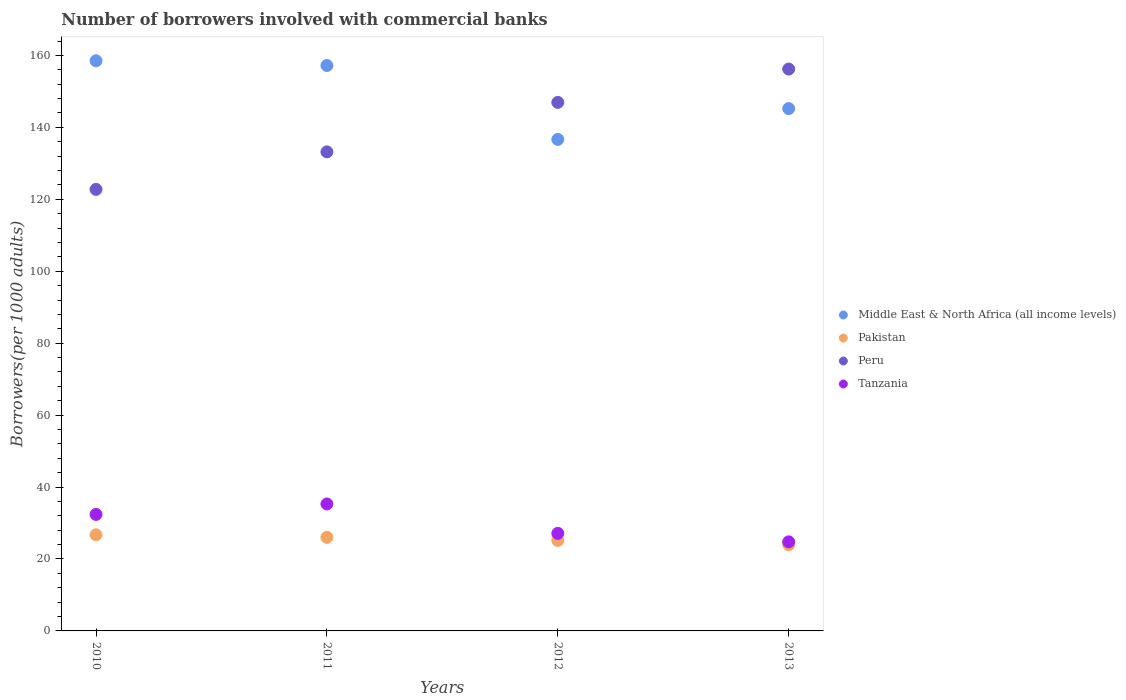What is the number of borrowers involved with commercial banks in Peru in 2013?
Offer a very short reply. 156.21. Across all years, what is the maximum number of borrowers involved with commercial banks in Peru?
Keep it short and to the point. 156.21. Across all years, what is the minimum number of borrowers involved with commercial banks in Peru?
Provide a short and direct response. 122.75. In which year was the number of borrowers involved with commercial banks in Peru maximum?
Your answer should be compact. 2013. What is the total number of borrowers involved with commercial banks in Tanzania in the graph?
Offer a very short reply. 119.57. What is the difference between the number of borrowers involved with commercial banks in Tanzania in 2012 and that in 2013?
Give a very brief answer. 2.35. What is the difference between the number of borrowers involved with commercial banks in Tanzania in 2010 and the number of borrowers involved with commercial banks in Pakistan in 2012?
Provide a short and direct response. 7.24. What is the average number of borrowers involved with commercial banks in Pakistan per year?
Your answer should be very brief. 25.46. In the year 2012, what is the difference between the number of borrowers involved with commercial banks in Tanzania and number of borrowers involved with commercial banks in Peru?
Provide a succinct answer. -119.83. In how many years, is the number of borrowers involved with commercial banks in Peru greater than 8?
Provide a short and direct response. 4. What is the ratio of the number of borrowers involved with commercial banks in Pakistan in 2010 to that in 2013?
Offer a terse response. 1.12. Is the number of borrowers involved with commercial banks in Peru in 2012 less than that in 2013?
Provide a succinct answer. Yes. What is the difference between the highest and the second highest number of borrowers involved with commercial banks in Pakistan?
Ensure brevity in your answer.  0.72. What is the difference between the highest and the lowest number of borrowers involved with commercial banks in Tanzania?
Ensure brevity in your answer.  10.53. Is the sum of the number of borrowers involved with commercial banks in Tanzania in 2011 and 2012 greater than the maximum number of borrowers involved with commercial banks in Pakistan across all years?
Give a very brief answer. Yes. Is it the case that in every year, the sum of the number of borrowers involved with commercial banks in Tanzania and number of borrowers involved with commercial banks in Pakistan  is greater than the number of borrowers involved with commercial banks in Middle East & North Africa (all income levels)?
Your answer should be compact. No. Does the number of borrowers involved with commercial banks in Pakistan monotonically increase over the years?
Your answer should be very brief. No. Is the number of borrowers involved with commercial banks in Tanzania strictly greater than the number of borrowers involved with commercial banks in Middle East & North Africa (all income levels) over the years?
Provide a succinct answer. No. Are the values on the major ticks of Y-axis written in scientific E-notation?
Offer a very short reply. No. Does the graph contain grids?
Make the answer very short. No. How many legend labels are there?
Make the answer very short. 4. What is the title of the graph?
Your answer should be compact. Number of borrowers involved with commercial banks. Does "Mauritius" appear as one of the legend labels in the graph?
Provide a succinct answer. No. What is the label or title of the Y-axis?
Your response must be concise. Borrowers(per 1000 adults). What is the Borrowers(per 1000 adults) of Middle East & North Africa (all income levels) in 2010?
Your response must be concise. 158.51. What is the Borrowers(per 1000 adults) in Pakistan in 2010?
Ensure brevity in your answer.  26.73. What is the Borrowers(per 1000 adults) of Peru in 2010?
Give a very brief answer. 122.75. What is the Borrowers(per 1000 adults) of Tanzania in 2010?
Offer a very short reply. 32.39. What is the Borrowers(per 1000 adults) in Middle East & North Africa (all income levels) in 2011?
Your answer should be compact. 157.2. What is the Borrowers(per 1000 adults) of Pakistan in 2011?
Offer a very short reply. 26.01. What is the Borrowers(per 1000 adults) in Peru in 2011?
Your answer should be very brief. 133.19. What is the Borrowers(per 1000 adults) of Tanzania in 2011?
Your answer should be very brief. 35.3. What is the Borrowers(per 1000 adults) in Middle East & North Africa (all income levels) in 2012?
Give a very brief answer. 136.65. What is the Borrowers(per 1000 adults) in Pakistan in 2012?
Make the answer very short. 25.15. What is the Borrowers(per 1000 adults) in Peru in 2012?
Give a very brief answer. 146.94. What is the Borrowers(per 1000 adults) of Tanzania in 2012?
Keep it short and to the point. 27.12. What is the Borrowers(per 1000 adults) of Middle East & North Africa (all income levels) in 2013?
Ensure brevity in your answer.  145.22. What is the Borrowers(per 1000 adults) of Pakistan in 2013?
Give a very brief answer. 23.97. What is the Borrowers(per 1000 adults) in Peru in 2013?
Give a very brief answer. 156.21. What is the Borrowers(per 1000 adults) in Tanzania in 2013?
Provide a succinct answer. 24.77. Across all years, what is the maximum Borrowers(per 1000 adults) of Middle East & North Africa (all income levels)?
Keep it short and to the point. 158.51. Across all years, what is the maximum Borrowers(per 1000 adults) in Pakistan?
Give a very brief answer. 26.73. Across all years, what is the maximum Borrowers(per 1000 adults) of Peru?
Keep it short and to the point. 156.21. Across all years, what is the maximum Borrowers(per 1000 adults) of Tanzania?
Your answer should be compact. 35.3. Across all years, what is the minimum Borrowers(per 1000 adults) in Middle East & North Africa (all income levels)?
Offer a terse response. 136.65. Across all years, what is the minimum Borrowers(per 1000 adults) of Pakistan?
Provide a short and direct response. 23.97. Across all years, what is the minimum Borrowers(per 1000 adults) in Peru?
Ensure brevity in your answer.  122.75. Across all years, what is the minimum Borrowers(per 1000 adults) of Tanzania?
Your response must be concise. 24.77. What is the total Borrowers(per 1000 adults) of Middle East & North Africa (all income levels) in the graph?
Your answer should be compact. 597.58. What is the total Borrowers(per 1000 adults) of Pakistan in the graph?
Provide a succinct answer. 101.85. What is the total Borrowers(per 1000 adults) of Peru in the graph?
Provide a succinct answer. 559.09. What is the total Borrowers(per 1000 adults) of Tanzania in the graph?
Your answer should be compact. 119.57. What is the difference between the Borrowers(per 1000 adults) in Middle East & North Africa (all income levels) in 2010 and that in 2011?
Provide a succinct answer. 1.32. What is the difference between the Borrowers(per 1000 adults) in Pakistan in 2010 and that in 2011?
Offer a terse response. 0.72. What is the difference between the Borrowers(per 1000 adults) of Peru in 2010 and that in 2011?
Offer a very short reply. -10.43. What is the difference between the Borrowers(per 1000 adults) of Tanzania in 2010 and that in 2011?
Your answer should be compact. -2.91. What is the difference between the Borrowers(per 1000 adults) of Middle East & North Africa (all income levels) in 2010 and that in 2012?
Your response must be concise. 21.87. What is the difference between the Borrowers(per 1000 adults) in Pakistan in 2010 and that in 2012?
Your answer should be very brief. 1.58. What is the difference between the Borrowers(per 1000 adults) in Peru in 2010 and that in 2012?
Offer a terse response. -24.19. What is the difference between the Borrowers(per 1000 adults) of Tanzania in 2010 and that in 2012?
Make the answer very short. 5.28. What is the difference between the Borrowers(per 1000 adults) in Middle East & North Africa (all income levels) in 2010 and that in 2013?
Your answer should be compact. 13.29. What is the difference between the Borrowers(per 1000 adults) of Pakistan in 2010 and that in 2013?
Your answer should be very brief. 2.76. What is the difference between the Borrowers(per 1000 adults) in Peru in 2010 and that in 2013?
Your answer should be very brief. -33.46. What is the difference between the Borrowers(per 1000 adults) in Tanzania in 2010 and that in 2013?
Keep it short and to the point. 7.63. What is the difference between the Borrowers(per 1000 adults) in Middle East & North Africa (all income levels) in 2011 and that in 2012?
Offer a terse response. 20.55. What is the difference between the Borrowers(per 1000 adults) of Pakistan in 2011 and that in 2012?
Provide a succinct answer. 0.86. What is the difference between the Borrowers(per 1000 adults) of Peru in 2011 and that in 2012?
Offer a very short reply. -13.75. What is the difference between the Borrowers(per 1000 adults) of Tanzania in 2011 and that in 2012?
Offer a very short reply. 8.18. What is the difference between the Borrowers(per 1000 adults) of Middle East & North Africa (all income levels) in 2011 and that in 2013?
Your answer should be very brief. 11.98. What is the difference between the Borrowers(per 1000 adults) of Pakistan in 2011 and that in 2013?
Keep it short and to the point. 2.04. What is the difference between the Borrowers(per 1000 adults) in Peru in 2011 and that in 2013?
Keep it short and to the point. -23.02. What is the difference between the Borrowers(per 1000 adults) in Tanzania in 2011 and that in 2013?
Make the answer very short. 10.53. What is the difference between the Borrowers(per 1000 adults) of Middle East & North Africa (all income levels) in 2012 and that in 2013?
Provide a short and direct response. -8.58. What is the difference between the Borrowers(per 1000 adults) in Pakistan in 2012 and that in 2013?
Offer a terse response. 1.18. What is the difference between the Borrowers(per 1000 adults) in Peru in 2012 and that in 2013?
Provide a succinct answer. -9.27. What is the difference between the Borrowers(per 1000 adults) of Tanzania in 2012 and that in 2013?
Ensure brevity in your answer.  2.35. What is the difference between the Borrowers(per 1000 adults) of Middle East & North Africa (all income levels) in 2010 and the Borrowers(per 1000 adults) of Pakistan in 2011?
Keep it short and to the point. 132.5. What is the difference between the Borrowers(per 1000 adults) in Middle East & North Africa (all income levels) in 2010 and the Borrowers(per 1000 adults) in Peru in 2011?
Keep it short and to the point. 25.33. What is the difference between the Borrowers(per 1000 adults) in Middle East & North Africa (all income levels) in 2010 and the Borrowers(per 1000 adults) in Tanzania in 2011?
Your answer should be compact. 123.22. What is the difference between the Borrowers(per 1000 adults) in Pakistan in 2010 and the Borrowers(per 1000 adults) in Peru in 2011?
Your answer should be compact. -106.46. What is the difference between the Borrowers(per 1000 adults) in Pakistan in 2010 and the Borrowers(per 1000 adults) in Tanzania in 2011?
Make the answer very short. -8.57. What is the difference between the Borrowers(per 1000 adults) in Peru in 2010 and the Borrowers(per 1000 adults) in Tanzania in 2011?
Give a very brief answer. 87.46. What is the difference between the Borrowers(per 1000 adults) of Middle East & North Africa (all income levels) in 2010 and the Borrowers(per 1000 adults) of Pakistan in 2012?
Your answer should be compact. 133.37. What is the difference between the Borrowers(per 1000 adults) of Middle East & North Africa (all income levels) in 2010 and the Borrowers(per 1000 adults) of Peru in 2012?
Give a very brief answer. 11.57. What is the difference between the Borrowers(per 1000 adults) in Middle East & North Africa (all income levels) in 2010 and the Borrowers(per 1000 adults) in Tanzania in 2012?
Give a very brief answer. 131.4. What is the difference between the Borrowers(per 1000 adults) of Pakistan in 2010 and the Borrowers(per 1000 adults) of Peru in 2012?
Your response must be concise. -120.21. What is the difference between the Borrowers(per 1000 adults) of Pakistan in 2010 and the Borrowers(per 1000 adults) of Tanzania in 2012?
Provide a short and direct response. -0.39. What is the difference between the Borrowers(per 1000 adults) in Peru in 2010 and the Borrowers(per 1000 adults) in Tanzania in 2012?
Offer a terse response. 95.64. What is the difference between the Borrowers(per 1000 adults) in Middle East & North Africa (all income levels) in 2010 and the Borrowers(per 1000 adults) in Pakistan in 2013?
Your answer should be compact. 134.55. What is the difference between the Borrowers(per 1000 adults) in Middle East & North Africa (all income levels) in 2010 and the Borrowers(per 1000 adults) in Peru in 2013?
Your answer should be compact. 2.3. What is the difference between the Borrowers(per 1000 adults) in Middle East & North Africa (all income levels) in 2010 and the Borrowers(per 1000 adults) in Tanzania in 2013?
Your answer should be very brief. 133.75. What is the difference between the Borrowers(per 1000 adults) of Pakistan in 2010 and the Borrowers(per 1000 adults) of Peru in 2013?
Make the answer very short. -129.48. What is the difference between the Borrowers(per 1000 adults) of Pakistan in 2010 and the Borrowers(per 1000 adults) of Tanzania in 2013?
Your response must be concise. 1.96. What is the difference between the Borrowers(per 1000 adults) in Peru in 2010 and the Borrowers(per 1000 adults) in Tanzania in 2013?
Make the answer very short. 97.99. What is the difference between the Borrowers(per 1000 adults) in Middle East & North Africa (all income levels) in 2011 and the Borrowers(per 1000 adults) in Pakistan in 2012?
Provide a short and direct response. 132.05. What is the difference between the Borrowers(per 1000 adults) in Middle East & North Africa (all income levels) in 2011 and the Borrowers(per 1000 adults) in Peru in 2012?
Give a very brief answer. 10.26. What is the difference between the Borrowers(per 1000 adults) of Middle East & North Africa (all income levels) in 2011 and the Borrowers(per 1000 adults) of Tanzania in 2012?
Keep it short and to the point. 130.08. What is the difference between the Borrowers(per 1000 adults) of Pakistan in 2011 and the Borrowers(per 1000 adults) of Peru in 2012?
Provide a short and direct response. -120.93. What is the difference between the Borrowers(per 1000 adults) in Pakistan in 2011 and the Borrowers(per 1000 adults) in Tanzania in 2012?
Ensure brevity in your answer.  -1.11. What is the difference between the Borrowers(per 1000 adults) of Peru in 2011 and the Borrowers(per 1000 adults) of Tanzania in 2012?
Keep it short and to the point. 106.07. What is the difference between the Borrowers(per 1000 adults) of Middle East & North Africa (all income levels) in 2011 and the Borrowers(per 1000 adults) of Pakistan in 2013?
Ensure brevity in your answer.  133.23. What is the difference between the Borrowers(per 1000 adults) of Middle East & North Africa (all income levels) in 2011 and the Borrowers(per 1000 adults) of Tanzania in 2013?
Ensure brevity in your answer.  132.43. What is the difference between the Borrowers(per 1000 adults) of Pakistan in 2011 and the Borrowers(per 1000 adults) of Peru in 2013?
Your response must be concise. -130.2. What is the difference between the Borrowers(per 1000 adults) in Pakistan in 2011 and the Borrowers(per 1000 adults) in Tanzania in 2013?
Offer a terse response. 1.24. What is the difference between the Borrowers(per 1000 adults) of Peru in 2011 and the Borrowers(per 1000 adults) of Tanzania in 2013?
Your answer should be very brief. 108.42. What is the difference between the Borrowers(per 1000 adults) of Middle East & North Africa (all income levels) in 2012 and the Borrowers(per 1000 adults) of Pakistan in 2013?
Keep it short and to the point. 112.68. What is the difference between the Borrowers(per 1000 adults) in Middle East & North Africa (all income levels) in 2012 and the Borrowers(per 1000 adults) in Peru in 2013?
Offer a terse response. -19.56. What is the difference between the Borrowers(per 1000 adults) of Middle East & North Africa (all income levels) in 2012 and the Borrowers(per 1000 adults) of Tanzania in 2013?
Your answer should be compact. 111.88. What is the difference between the Borrowers(per 1000 adults) of Pakistan in 2012 and the Borrowers(per 1000 adults) of Peru in 2013?
Provide a succinct answer. -131.06. What is the difference between the Borrowers(per 1000 adults) of Pakistan in 2012 and the Borrowers(per 1000 adults) of Tanzania in 2013?
Ensure brevity in your answer.  0.38. What is the difference between the Borrowers(per 1000 adults) of Peru in 2012 and the Borrowers(per 1000 adults) of Tanzania in 2013?
Ensure brevity in your answer.  122.18. What is the average Borrowers(per 1000 adults) of Middle East & North Africa (all income levels) per year?
Provide a succinct answer. 149.39. What is the average Borrowers(per 1000 adults) of Pakistan per year?
Your answer should be compact. 25.46. What is the average Borrowers(per 1000 adults) in Peru per year?
Provide a short and direct response. 139.77. What is the average Borrowers(per 1000 adults) of Tanzania per year?
Offer a terse response. 29.89. In the year 2010, what is the difference between the Borrowers(per 1000 adults) of Middle East & North Africa (all income levels) and Borrowers(per 1000 adults) of Pakistan?
Keep it short and to the point. 131.78. In the year 2010, what is the difference between the Borrowers(per 1000 adults) of Middle East & North Africa (all income levels) and Borrowers(per 1000 adults) of Peru?
Provide a short and direct response. 35.76. In the year 2010, what is the difference between the Borrowers(per 1000 adults) in Middle East & North Africa (all income levels) and Borrowers(per 1000 adults) in Tanzania?
Make the answer very short. 126.12. In the year 2010, what is the difference between the Borrowers(per 1000 adults) of Pakistan and Borrowers(per 1000 adults) of Peru?
Your answer should be very brief. -96.02. In the year 2010, what is the difference between the Borrowers(per 1000 adults) in Pakistan and Borrowers(per 1000 adults) in Tanzania?
Make the answer very short. -5.66. In the year 2010, what is the difference between the Borrowers(per 1000 adults) of Peru and Borrowers(per 1000 adults) of Tanzania?
Your response must be concise. 90.36. In the year 2011, what is the difference between the Borrowers(per 1000 adults) in Middle East & North Africa (all income levels) and Borrowers(per 1000 adults) in Pakistan?
Provide a succinct answer. 131.19. In the year 2011, what is the difference between the Borrowers(per 1000 adults) of Middle East & North Africa (all income levels) and Borrowers(per 1000 adults) of Peru?
Keep it short and to the point. 24.01. In the year 2011, what is the difference between the Borrowers(per 1000 adults) of Middle East & North Africa (all income levels) and Borrowers(per 1000 adults) of Tanzania?
Your answer should be compact. 121.9. In the year 2011, what is the difference between the Borrowers(per 1000 adults) in Pakistan and Borrowers(per 1000 adults) in Peru?
Offer a terse response. -107.18. In the year 2011, what is the difference between the Borrowers(per 1000 adults) of Pakistan and Borrowers(per 1000 adults) of Tanzania?
Keep it short and to the point. -9.29. In the year 2011, what is the difference between the Borrowers(per 1000 adults) of Peru and Borrowers(per 1000 adults) of Tanzania?
Offer a terse response. 97.89. In the year 2012, what is the difference between the Borrowers(per 1000 adults) in Middle East & North Africa (all income levels) and Borrowers(per 1000 adults) in Pakistan?
Provide a succinct answer. 111.5. In the year 2012, what is the difference between the Borrowers(per 1000 adults) in Middle East & North Africa (all income levels) and Borrowers(per 1000 adults) in Peru?
Offer a very short reply. -10.29. In the year 2012, what is the difference between the Borrowers(per 1000 adults) of Middle East & North Africa (all income levels) and Borrowers(per 1000 adults) of Tanzania?
Make the answer very short. 109.53. In the year 2012, what is the difference between the Borrowers(per 1000 adults) in Pakistan and Borrowers(per 1000 adults) in Peru?
Ensure brevity in your answer.  -121.79. In the year 2012, what is the difference between the Borrowers(per 1000 adults) of Pakistan and Borrowers(per 1000 adults) of Tanzania?
Offer a very short reply. -1.97. In the year 2012, what is the difference between the Borrowers(per 1000 adults) in Peru and Borrowers(per 1000 adults) in Tanzania?
Offer a very short reply. 119.83. In the year 2013, what is the difference between the Borrowers(per 1000 adults) in Middle East & North Africa (all income levels) and Borrowers(per 1000 adults) in Pakistan?
Your answer should be compact. 121.26. In the year 2013, what is the difference between the Borrowers(per 1000 adults) in Middle East & North Africa (all income levels) and Borrowers(per 1000 adults) in Peru?
Your response must be concise. -10.99. In the year 2013, what is the difference between the Borrowers(per 1000 adults) in Middle East & North Africa (all income levels) and Borrowers(per 1000 adults) in Tanzania?
Your answer should be compact. 120.46. In the year 2013, what is the difference between the Borrowers(per 1000 adults) in Pakistan and Borrowers(per 1000 adults) in Peru?
Give a very brief answer. -132.24. In the year 2013, what is the difference between the Borrowers(per 1000 adults) in Pakistan and Borrowers(per 1000 adults) in Tanzania?
Your response must be concise. -0.8. In the year 2013, what is the difference between the Borrowers(per 1000 adults) in Peru and Borrowers(per 1000 adults) in Tanzania?
Keep it short and to the point. 131.44. What is the ratio of the Borrowers(per 1000 adults) in Middle East & North Africa (all income levels) in 2010 to that in 2011?
Give a very brief answer. 1.01. What is the ratio of the Borrowers(per 1000 adults) in Pakistan in 2010 to that in 2011?
Offer a very short reply. 1.03. What is the ratio of the Borrowers(per 1000 adults) of Peru in 2010 to that in 2011?
Keep it short and to the point. 0.92. What is the ratio of the Borrowers(per 1000 adults) of Tanzania in 2010 to that in 2011?
Provide a short and direct response. 0.92. What is the ratio of the Borrowers(per 1000 adults) in Middle East & North Africa (all income levels) in 2010 to that in 2012?
Keep it short and to the point. 1.16. What is the ratio of the Borrowers(per 1000 adults) in Pakistan in 2010 to that in 2012?
Give a very brief answer. 1.06. What is the ratio of the Borrowers(per 1000 adults) in Peru in 2010 to that in 2012?
Offer a terse response. 0.84. What is the ratio of the Borrowers(per 1000 adults) in Tanzania in 2010 to that in 2012?
Your answer should be compact. 1.19. What is the ratio of the Borrowers(per 1000 adults) of Middle East & North Africa (all income levels) in 2010 to that in 2013?
Make the answer very short. 1.09. What is the ratio of the Borrowers(per 1000 adults) in Pakistan in 2010 to that in 2013?
Your response must be concise. 1.12. What is the ratio of the Borrowers(per 1000 adults) in Peru in 2010 to that in 2013?
Give a very brief answer. 0.79. What is the ratio of the Borrowers(per 1000 adults) in Tanzania in 2010 to that in 2013?
Offer a very short reply. 1.31. What is the ratio of the Borrowers(per 1000 adults) of Middle East & North Africa (all income levels) in 2011 to that in 2012?
Provide a short and direct response. 1.15. What is the ratio of the Borrowers(per 1000 adults) of Pakistan in 2011 to that in 2012?
Provide a succinct answer. 1.03. What is the ratio of the Borrowers(per 1000 adults) of Peru in 2011 to that in 2012?
Make the answer very short. 0.91. What is the ratio of the Borrowers(per 1000 adults) of Tanzania in 2011 to that in 2012?
Your response must be concise. 1.3. What is the ratio of the Borrowers(per 1000 adults) in Middle East & North Africa (all income levels) in 2011 to that in 2013?
Your answer should be very brief. 1.08. What is the ratio of the Borrowers(per 1000 adults) in Pakistan in 2011 to that in 2013?
Your response must be concise. 1.09. What is the ratio of the Borrowers(per 1000 adults) of Peru in 2011 to that in 2013?
Make the answer very short. 0.85. What is the ratio of the Borrowers(per 1000 adults) in Tanzania in 2011 to that in 2013?
Make the answer very short. 1.43. What is the ratio of the Borrowers(per 1000 adults) in Middle East & North Africa (all income levels) in 2012 to that in 2013?
Provide a short and direct response. 0.94. What is the ratio of the Borrowers(per 1000 adults) of Pakistan in 2012 to that in 2013?
Offer a terse response. 1.05. What is the ratio of the Borrowers(per 1000 adults) of Peru in 2012 to that in 2013?
Offer a very short reply. 0.94. What is the ratio of the Borrowers(per 1000 adults) in Tanzania in 2012 to that in 2013?
Give a very brief answer. 1.09. What is the difference between the highest and the second highest Borrowers(per 1000 adults) of Middle East & North Africa (all income levels)?
Your response must be concise. 1.32. What is the difference between the highest and the second highest Borrowers(per 1000 adults) in Pakistan?
Give a very brief answer. 0.72. What is the difference between the highest and the second highest Borrowers(per 1000 adults) of Peru?
Make the answer very short. 9.27. What is the difference between the highest and the second highest Borrowers(per 1000 adults) in Tanzania?
Offer a very short reply. 2.91. What is the difference between the highest and the lowest Borrowers(per 1000 adults) of Middle East & North Africa (all income levels)?
Make the answer very short. 21.87. What is the difference between the highest and the lowest Borrowers(per 1000 adults) in Pakistan?
Make the answer very short. 2.76. What is the difference between the highest and the lowest Borrowers(per 1000 adults) in Peru?
Your answer should be compact. 33.46. What is the difference between the highest and the lowest Borrowers(per 1000 adults) of Tanzania?
Offer a terse response. 10.53. 